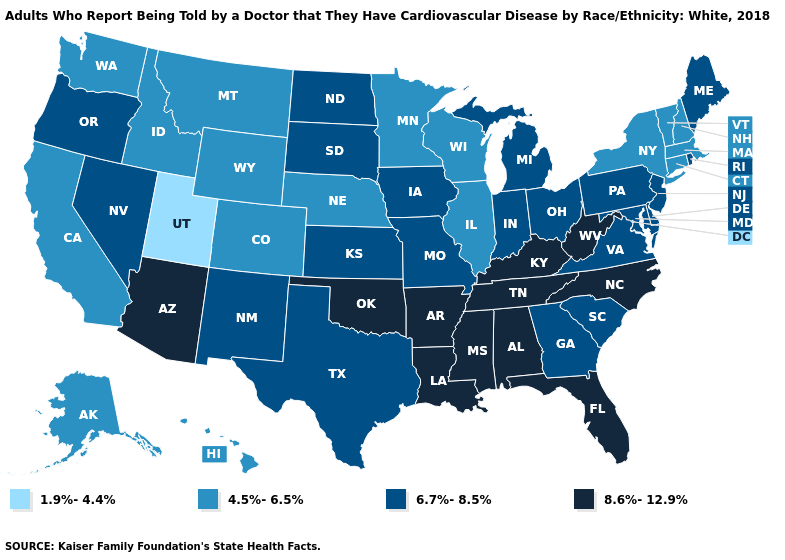What is the value of Wisconsin?
Write a very short answer. 4.5%-6.5%. Among the states that border South Dakota , which have the lowest value?
Answer briefly. Minnesota, Montana, Nebraska, Wyoming. Name the states that have a value in the range 8.6%-12.9%?
Be succinct. Alabama, Arizona, Arkansas, Florida, Kentucky, Louisiana, Mississippi, North Carolina, Oklahoma, Tennessee, West Virginia. Name the states that have a value in the range 8.6%-12.9%?
Answer briefly. Alabama, Arizona, Arkansas, Florida, Kentucky, Louisiana, Mississippi, North Carolina, Oklahoma, Tennessee, West Virginia. Name the states that have a value in the range 4.5%-6.5%?
Give a very brief answer. Alaska, California, Colorado, Connecticut, Hawaii, Idaho, Illinois, Massachusetts, Minnesota, Montana, Nebraska, New Hampshire, New York, Vermont, Washington, Wisconsin, Wyoming. Is the legend a continuous bar?
Quick response, please. No. Does South Dakota have the same value as Idaho?
Be succinct. No. What is the highest value in the USA?
Answer briefly. 8.6%-12.9%. Does Maryland have the highest value in the South?
Short answer required. No. Does South Carolina have the lowest value in the South?
Give a very brief answer. Yes. Name the states that have a value in the range 6.7%-8.5%?
Be succinct. Delaware, Georgia, Indiana, Iowa, Kansas, Maine, Maryland, Michigan, Missouri, Nevada, New Jersey, New Mexico, North Dakota, Ohio, Oregon, Pennsylvania, Rhode Island, South Carolina, South Dakota, Texas, Virginia. What is the highest value in the MidWest ?
Short answer required. 6.7%-8.5%. Which states have the lowest value in the MidWest?
Write a very short answer. Illinois, Minnesota, Nebraska, Wisconsin. Name the states that have a value in the range 8.6%-12.9%?
Keep it brief. Alabama, Arizona, Arkansas, Florida, Kentucky, Louisiana, Mississippi, North Carolina, Oklahoma, Tennessee, West Virginia. Does Hawaii have the highest value in the West?
Quick response, please. No. 